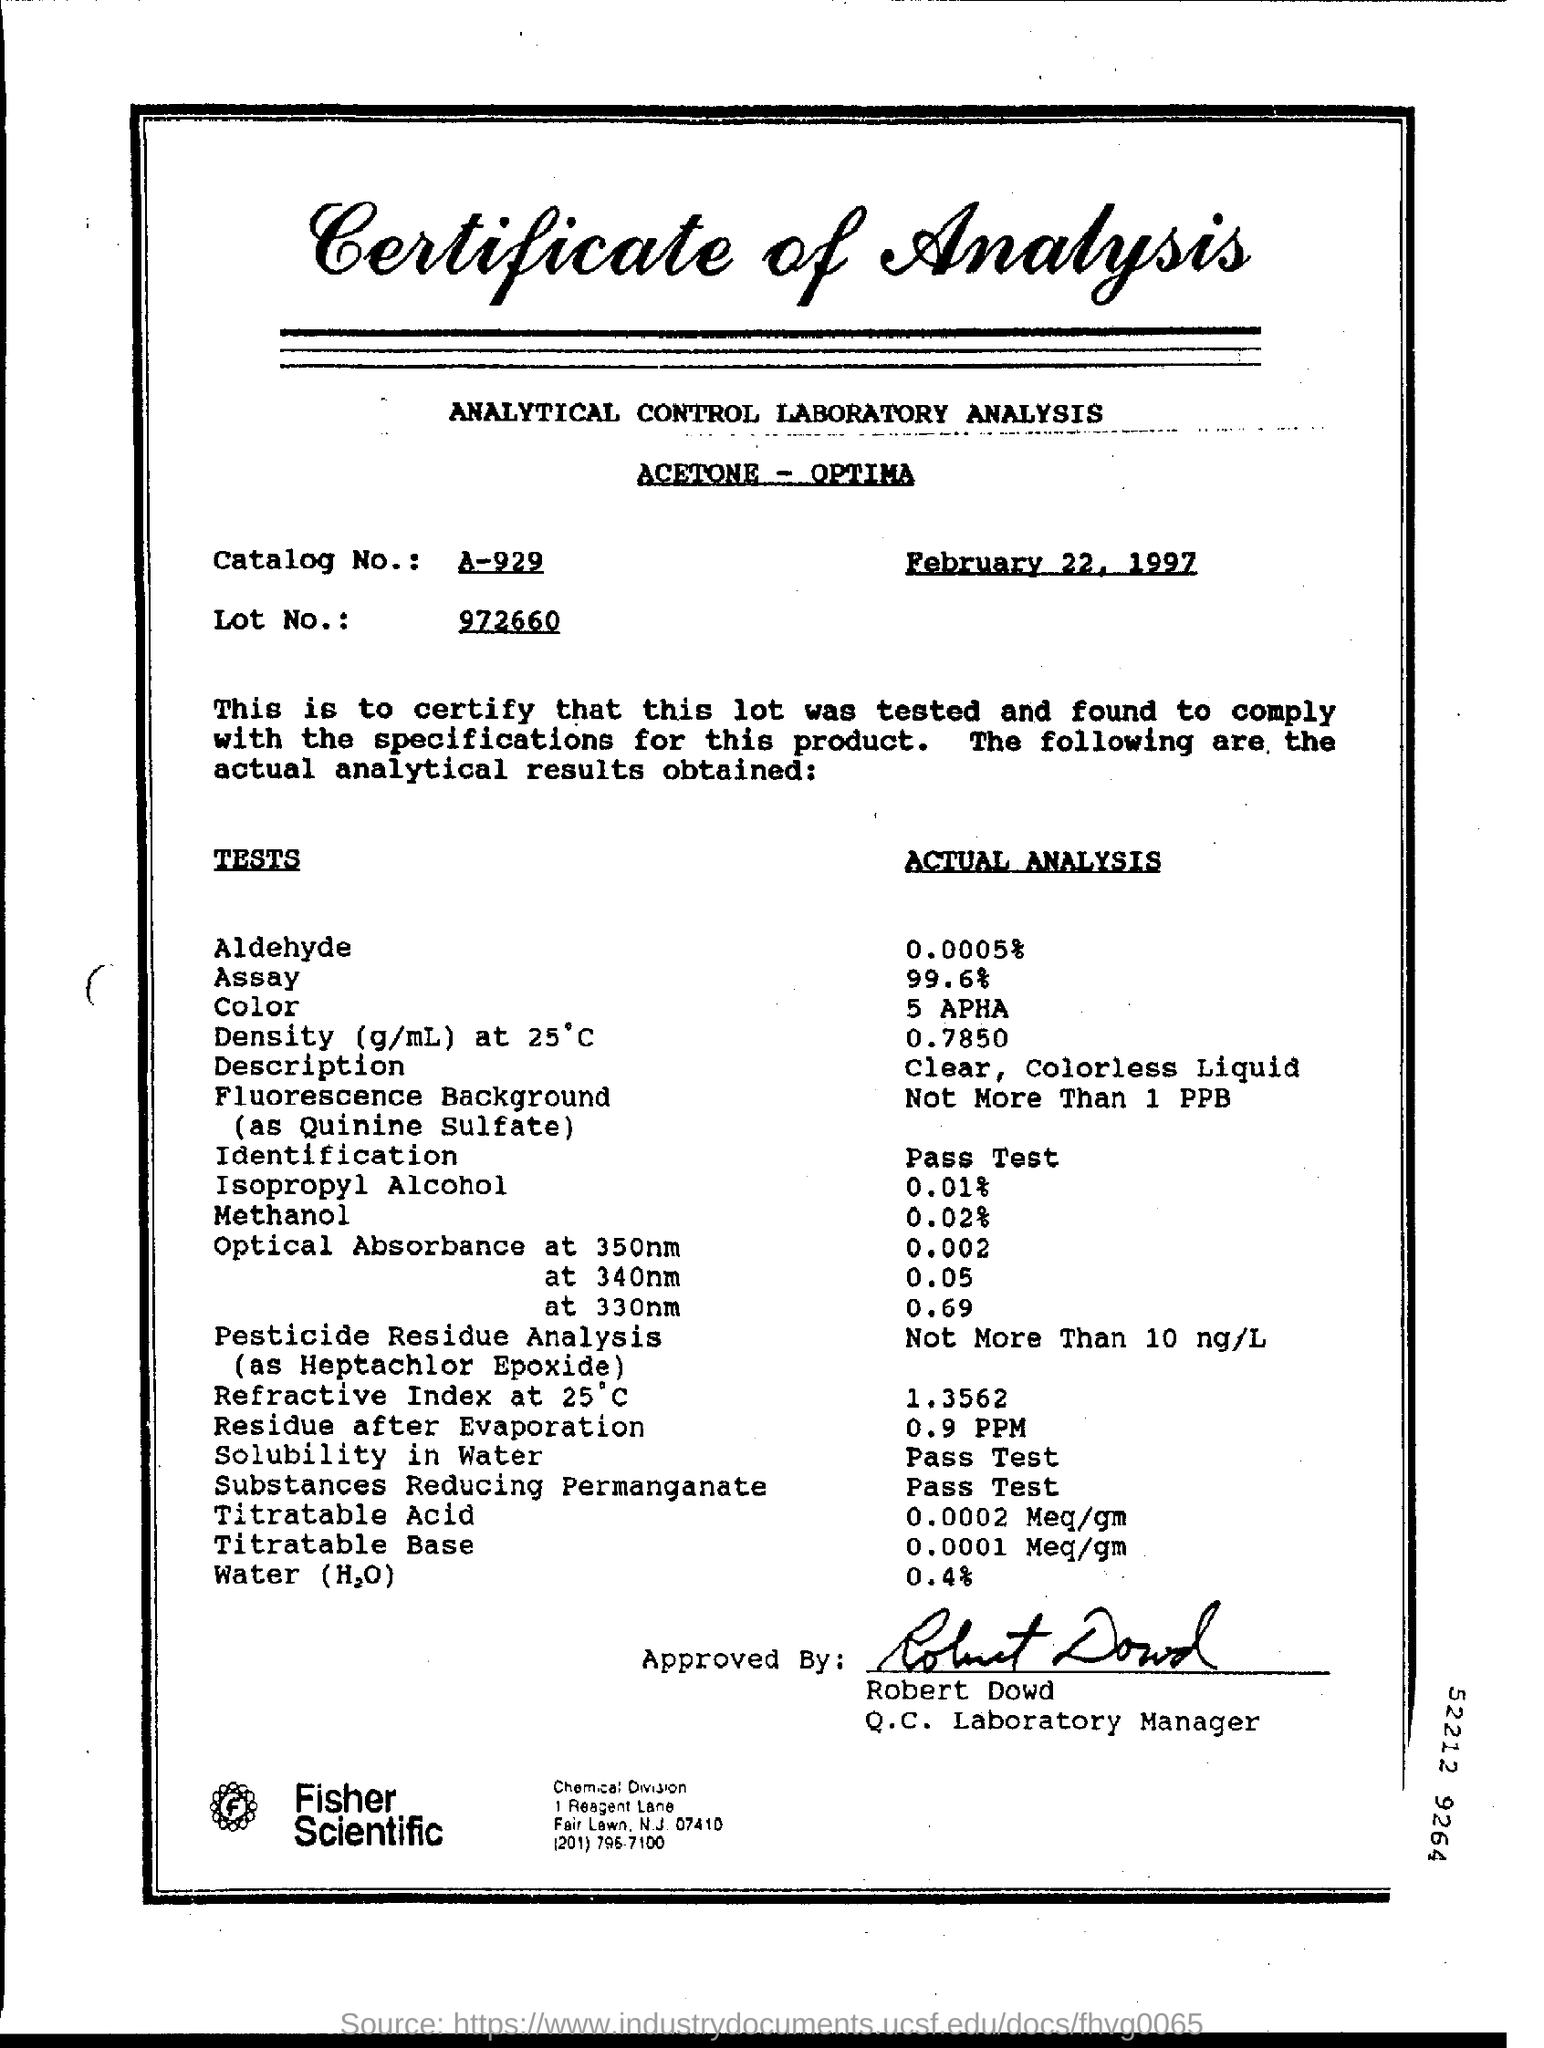Who approved this document?
Offer a terse response. Robert Dowd. Who signed the document?
Your response must be concise. Robert Dowd. What is the % of actual analysis of water?
Keep it short and to the point. 0.4. 